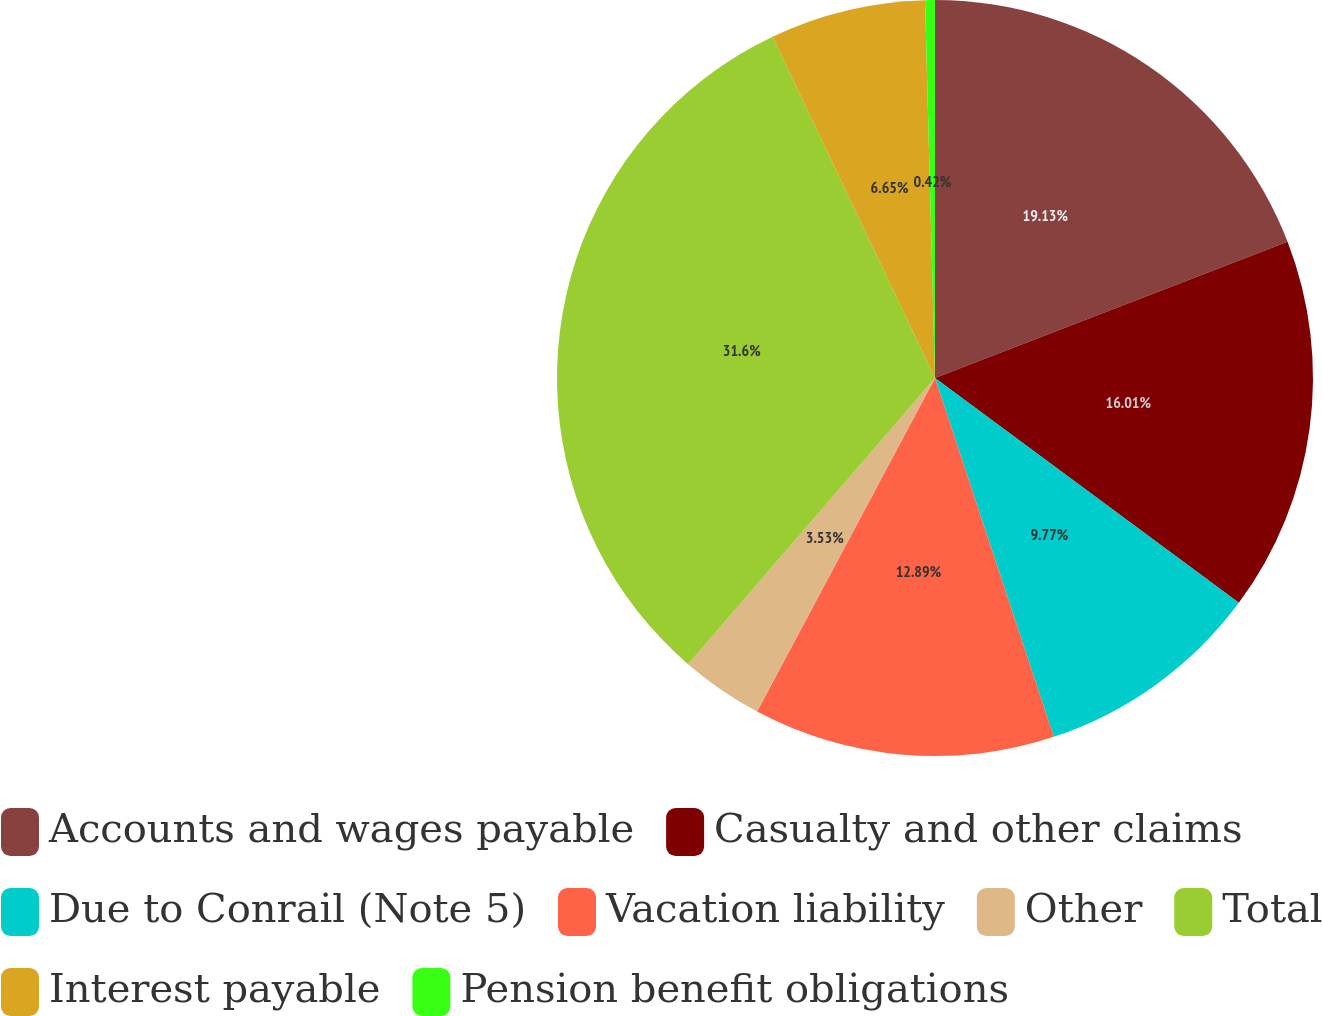Convert chart to OTSL. <chart><loc_0><loc_0><loc_500><loc_500><pie_chart><fcel>Accounts and wages payable<fcel>Casualty and other claims<fcel>Due to Conrail (Note 5)<fcel>Vacation liability<fcel>Other<fcel>Total<fcel>Interest payable<fcel>Pension benefit obligations<nl><fcel>19.13%<fcel>16.01%<fcel>9.77%<fcel>12.89%<fcel>3.53%<fcel>31.6%<fcel>6.65%<fcel>0.42%<nl></chart> 